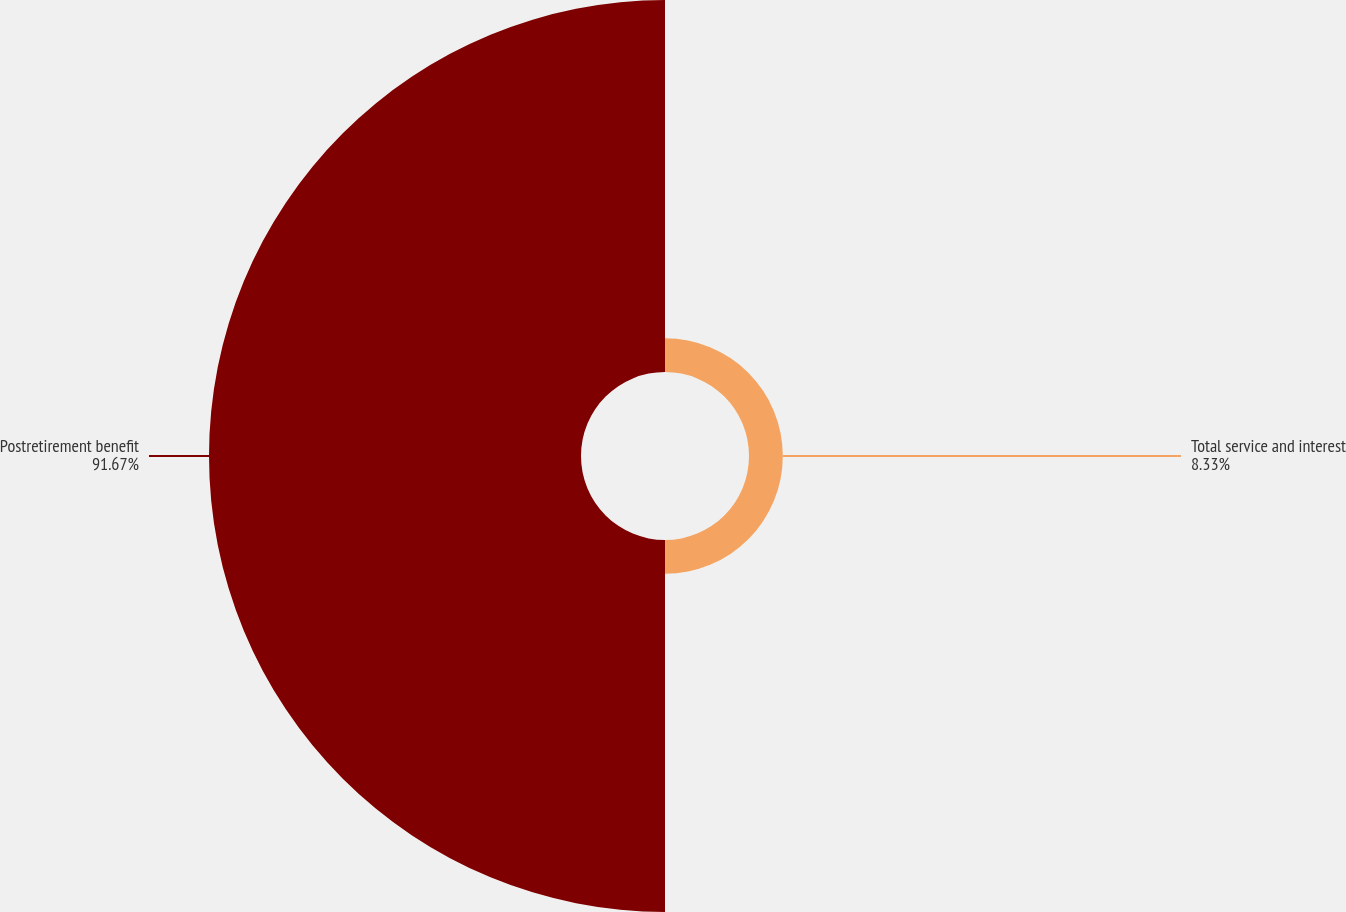<chart> <loc_0><loc_0><loc_500><loc_500><pie_chart><fcel>Total service and interest<fcel>Postretirement benefit<nl><fcel>8.33%<fcel>91.67%<nl></chart> 